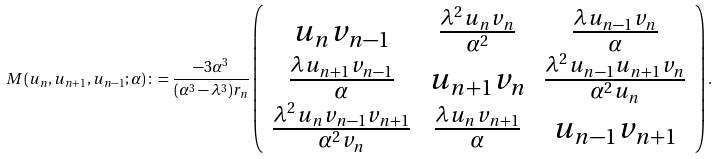<formula> <loc_0><loc_0><loc_500><loc_500>M ( { u } _ { n } , { u } _ { n + 1 } , { u } _ { n - 1 } ; \alpha ) \colon = \frac { - 3 \alpha ^ { 3 } } { ( \alpha ^ { 3 } - \lambda ^ { 3 } ) { r } _ { n } } \left ( \begin{array} { c c c } u _ { n } v _ { n - 1 } & \frac { \lambda ^ { 2 } u _ { n } v _ { n } } { \alpha ^ { 2 } } & \frac { \lambda u _ { n - 1 } v _ { n } } { \alpha } \\ \frac { \lambda u _ { n + 1 } v _ { n - 1 } } { \alpha } & u _ { n + 1 } v _ { n } & \frac { \lambda ^ { 2 } u _ { n - 1 } u _ { n + 1 } v _ { n } } { \alpha ^ { 2 } u _ { n } } \\ \frac { \lambda ^ { 2 } u _ { n } v _ { n - 1 } v _ { n + 1 } } { \alpha ^ { 2 } v _ { n } } & \frac { \lambda u _ { n } v _ { n + 1 } } { \alpha } & u _ { n - 1 } v _ { n + 1 } \end{array} \right ) .</formula> 